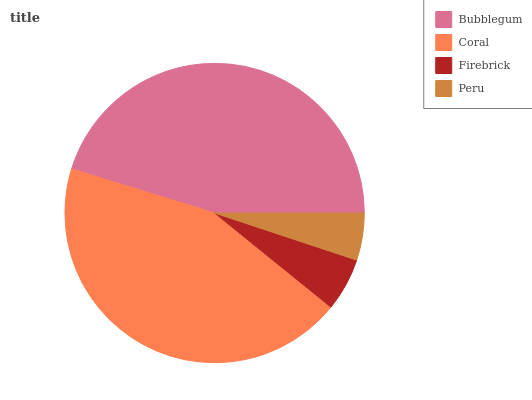Is Peru the minimum?
Answer yes or no. Yes. Is Bubblegum the maximum?
Answer yes or no. Yes. Is Coral the minimum?
Answer yes or no. No. Is Coral the maximum?
Answer yes or no. No. Is Bubblegum greater than Coral?
Answer yes or no. Yes. Is Coral less than Bubblegum?
Answer yes or no. Yes. Is Coral greater than Bubblegum?
Answer yes or no. No. Is Bubblegum less than Coral?
Answer yes or no. No. Is Coral the high median?
Answer yes or no. Yes. Is Firebrick the low median?
Answer yes or no. Yes. Is Bubblegum the high median?
Answer yes or no. No. Is Bubblegum the low median?
Answer yes or no. No. 